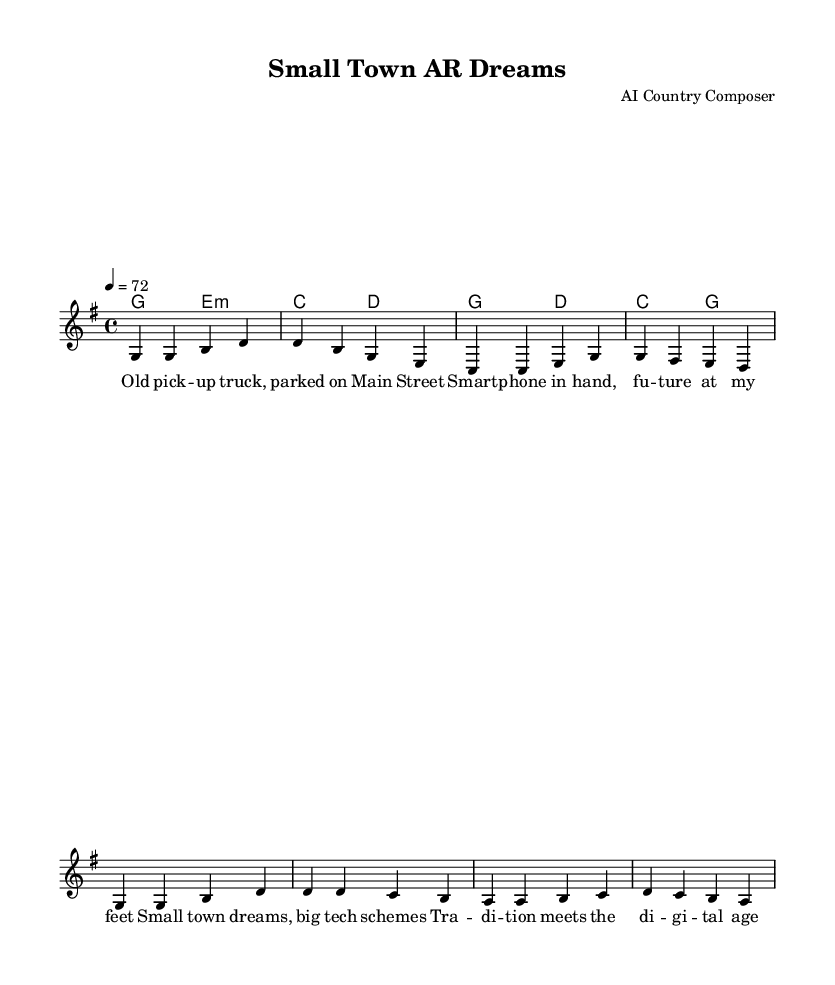What is the key signature of this music? The key signature indicated in the music is G major, which includes one sharp (F#).
Answer: G major What is the time signature of this music? The time signature stated in the music is 4/4, meaning there are four beats per measure.
Answer: 4/4 What is the tempo marking of this music? The tempo marking is provided as a quarter note equals 72 beats per minute, indicating how fast the piece should be played.
Answer: 72 How many measures are in the verse section? The verse section consists of four measures, as seen in the structured melody with the first eight notes grouped into two sets of four.
Answer: Four Which chord supports the first measure of the verse? The chord indicated for the first measure of the verse is G major, as shown in the chord names above the melody.
Answer: G major What theme is explored in the lyrics? The lyrics reflect the theme of blending traditional small-town life with modern technology, capturing the fusion of old and new.
Answer: Tradition meets technology What type of musical piece is reflected in this sheet music? The structure and lyrical content signify that this piece is a country ballad, focusing on personal and relatable experiences.
Answer: Country ballad 